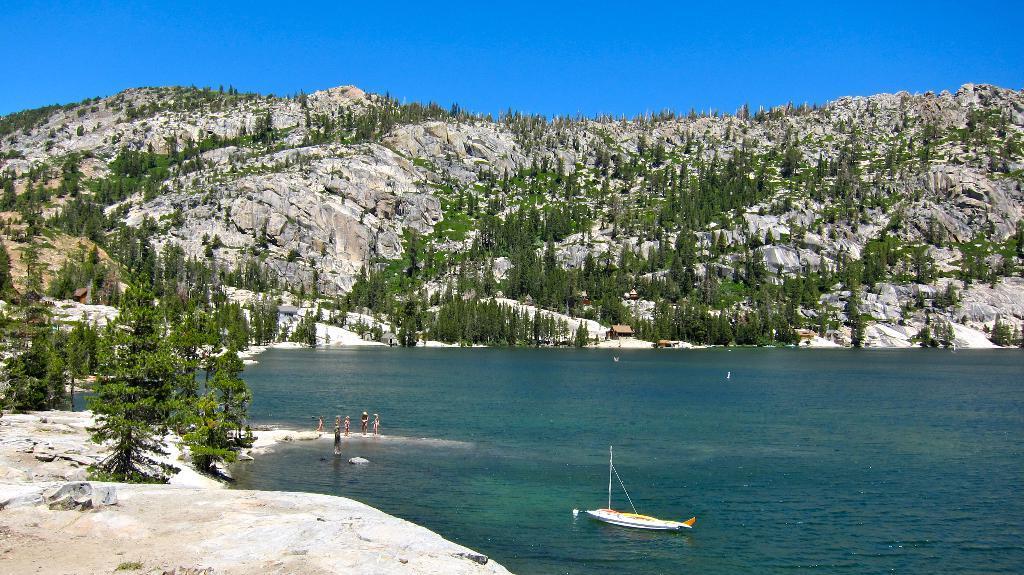In one or two sentences, can you explain what this image depicts? In this picture we can see a boat on water, trees, mountains and some persons standing on the ground and in the background we can see the sky. 